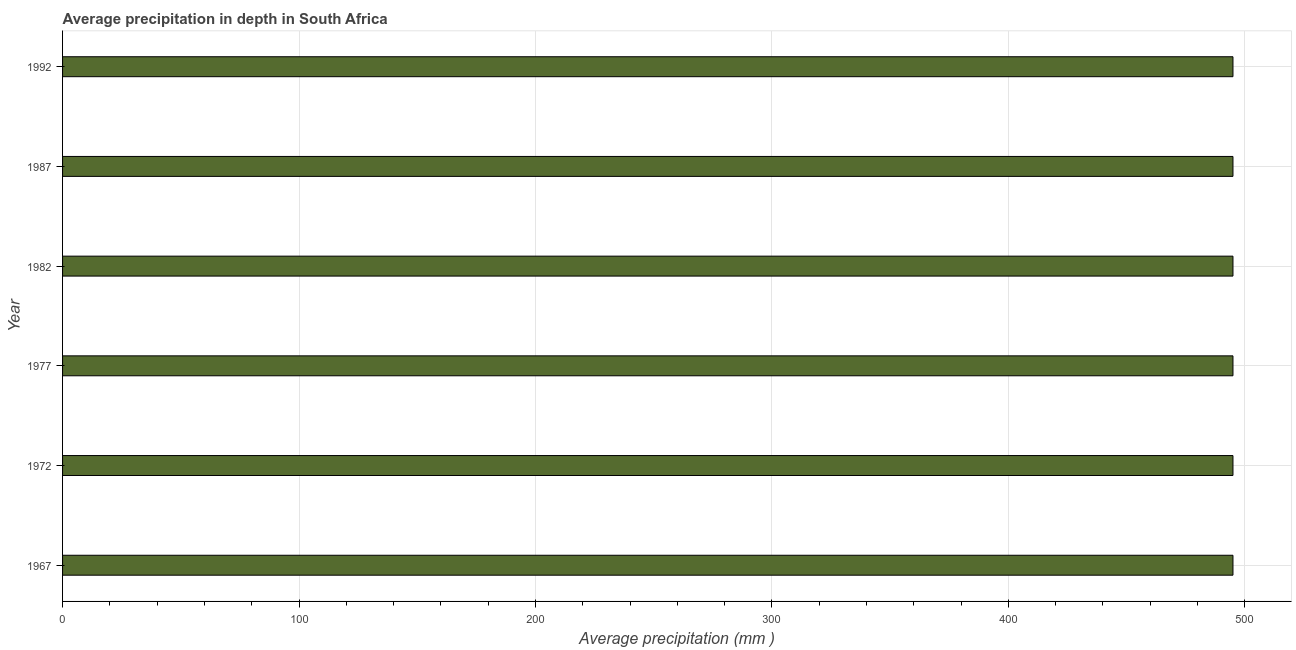Does the graph contain any zero values?
Your answer should be very brief. No. What is the title of the graph?
Your answer should be very brief. Average precipitation in depth in South Africa. What is the label or title of the X-axis?
Give a very brief answer. Average precipitation (mm ). What is the average precipitation in depth in 1987?
Keep it short and to the point. 495. Across all years, what is the maximum average precipitation in depth?
Your answer should be very brief. 495. Across all years, what is the minimum average precipitation in depth?
Offer a terse response. 495. In which year was the average precipitation in depth maximum?
Provide a short and direct response. 1967. In which year was the average precipitation in depth minimum?
Provide a succinct answer. 1967. What is the sum of the average precipitation in depth?
Your answer should be very brief. 2970. What is the average average precipitation in depth per year?
Your answer should be very brief. 495. What is the median average precipitation in depth?
Your answer should be compact. 495. In how many years, is the average precipitation in depth greater than 380 mm?
Give a very brief answer. 6. Do a majority of the years between 1987 and 1967 (inclusive) have average precipitation in depth greater than 40 mm?
Keep it short and to the point. Yes. Is the average precipitation in depth in 1967 less than that in 1992?
Keep it short and to the point. No. Is the difference between the average precipitation in depth in 1982 and 1987 greater than the difference between any two years?
Keep it short and to the point. Yes. Is the sum of the average precipitation in depth in 1972 and 1977 greater than the maximum average precipitation in depth across all years?
Provide a short and direct response. Yes. What is the difference between the highest and the lowest average precipitation in depth?
Offer a very short reply. 0. How many bars are there?
Your answer should be compact. 6. How many years are there in the graph?
Provide a succinct answer. 6. Are the values on the major ticks of X-axis written in scientific E-notation?
Offer a terse response. No. What is the Average precipitation (mm ) of 1967?
Offer a very short reply. 495. What is the Average precipitation (mm ) in 1972?
Your response must be concise. 495. What is the Average precipitation (mm ) of 1977?
Provide a short and direct response. 495. What is the Average precipitation (mm ) of 1982?
Keep it short and to the point. 495. What is the Average precipitation (mm ) in 1987?
Give a very brief answer. 495. What is the Average precipitation (mm ) of 1992?
Your response must be concise. 495. What is the difference between the Average precipitation (mm ) in 1967 and 1987?
Ensure brevity in your answer.  0. What is the difference between the Average precipitation (mm ) in 1972 and 1982?
Ensure brevity in your answer.  0. What is the difference between the Average precipitation (mm ) in 1977 and 1982?
Ensure brevity in your answer.  0. What is the difference between the Average precipitation (mm ) in 1977 and 1992?
Your answer should be very brief. 0. What is the difference between the Average precipitation (mm ) in 1982 and 1987?
Make the answer very short. 0. What is the difference between the Average precipitation (mm ) in 1982 and 1992?
Make the answer very short. 0. What is the difference between the Average precipitation (mm ) in 1987 and 1992?
Give a very brief answer. 0. What is the ratio of the Average precipitation (mm ) in 1967 to that in 1987?
Your answer should be compact. 1. What is the ratio of the Average precipitation (mm ) in 1972 to that in 1977?
Give a very brief answer. 1. What is the ratio of the Average precipitation (mm ) in 1972 to that in 1982?
Your answer should be very brief. 1. What is the ratio of the Average precipitation (mm ) in 1972 to that in 1987?
Your response must be concise. 1. What is the ratio of the Average precipitation (mm ) in 1972 to that in 1992?
Ensure brevity in your answer.  1. What is the ratio of the Average precipitation (mm ) in 1982 to that in 1987?
Ensure brevity in your answer.  1. 